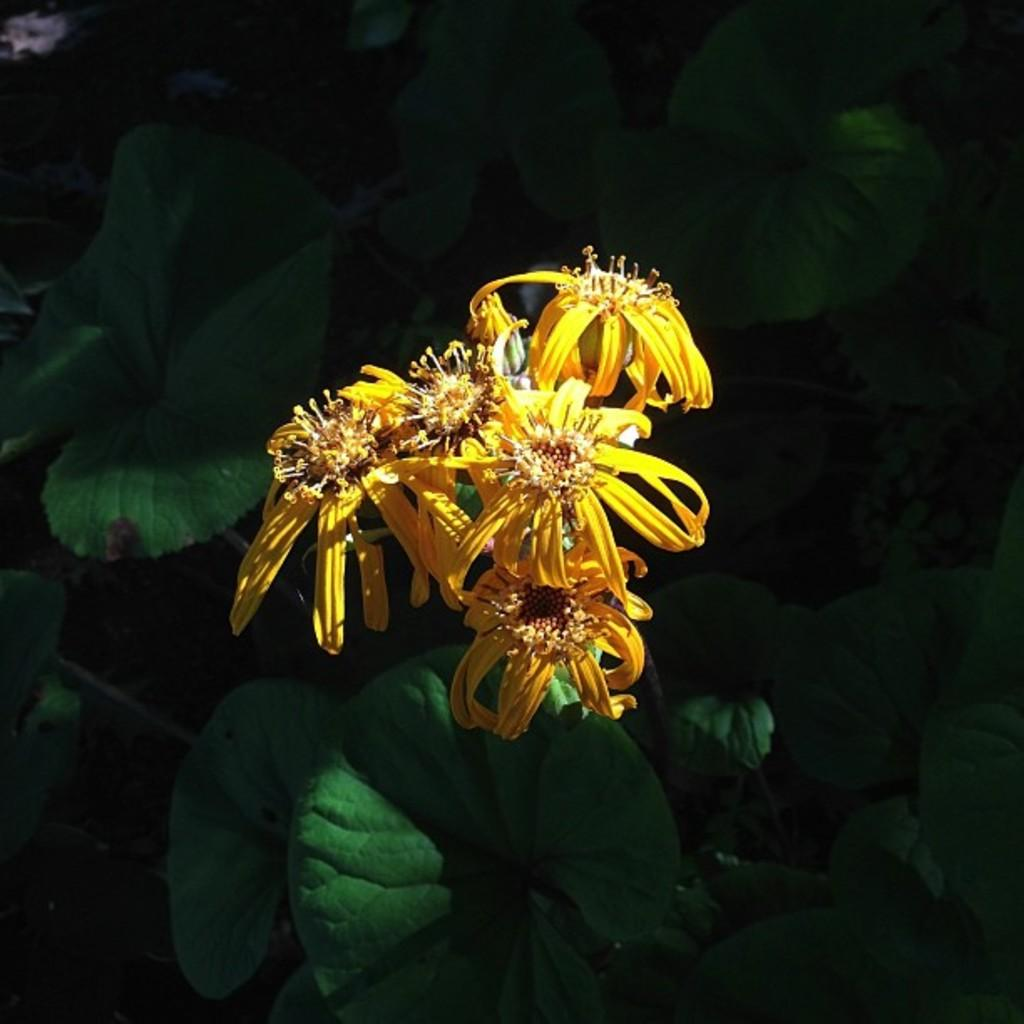What type of living organisms can be seen in the image? Plants can be seen in the image. What color are the flowers on the plants? The flowers on the plants are yellow. Can you describe the kitty's experience with the geese in the image? There is no kitty or geese present in the image, so it is not possible to describe their experience together. 